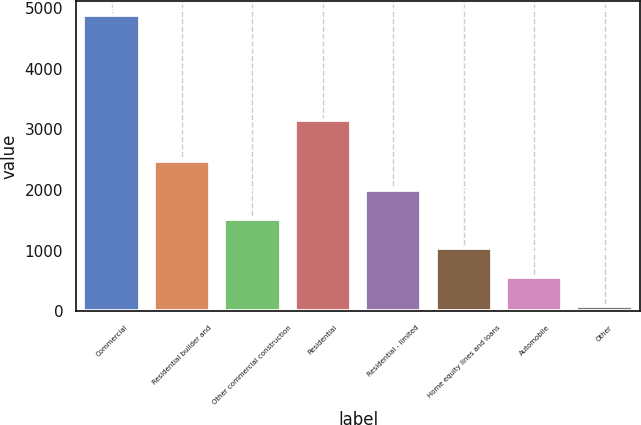<chart> <loc_0><loc_0><loc_500><loc_500><bar_chart><fcel>Commercial<fcel>Residential builder and<fcel>Other commercial construction<fcel>Residential<fcel>Residential - limited<fcel>Home equity lines and loans<fcel>Automobile<fcel>Other<nl><fcel>4878<fcel>2480.5<fcel>1521.5<fcel>3154<fcel>2001<fcel>1042<fcel>562.5<fcel>83<nl></chart> 